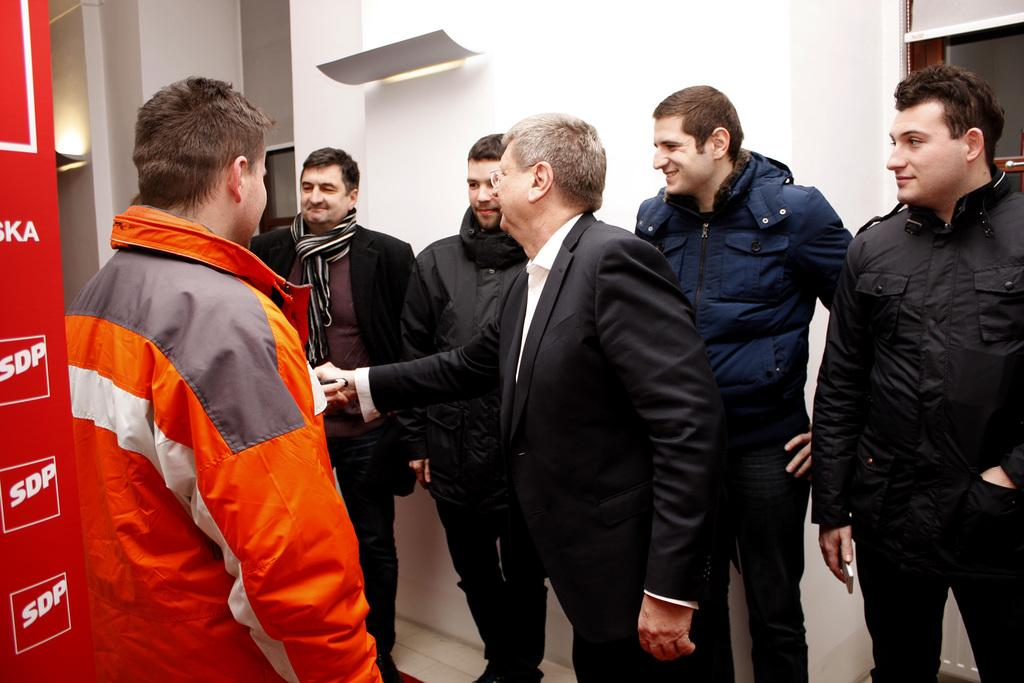How many people are in the image? There are multiple persons in the image. Where are the persons located in the image? The persons are standing in a room. What can be seen in the background of the image? There is a wall visible in the background. What type of clothing are the persons wearing? The persons are wearing winter clothes. Can you see any magic happening in the image? There is no magic present in the image; it features multiple persons standing in a room wearing winter clothes. Is there an ocean visible in the image? There is no ocean present in the image; it is set in a room with a wall visible in the background. 